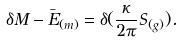<formula> <loc_0><loc_0><loc_500><loc_500>\delta M - \bar { E } _ { ( m ) } = \delta ( \frac { \kappa } { 2 \pi } S _ { ( g ) } ) .</formula> 